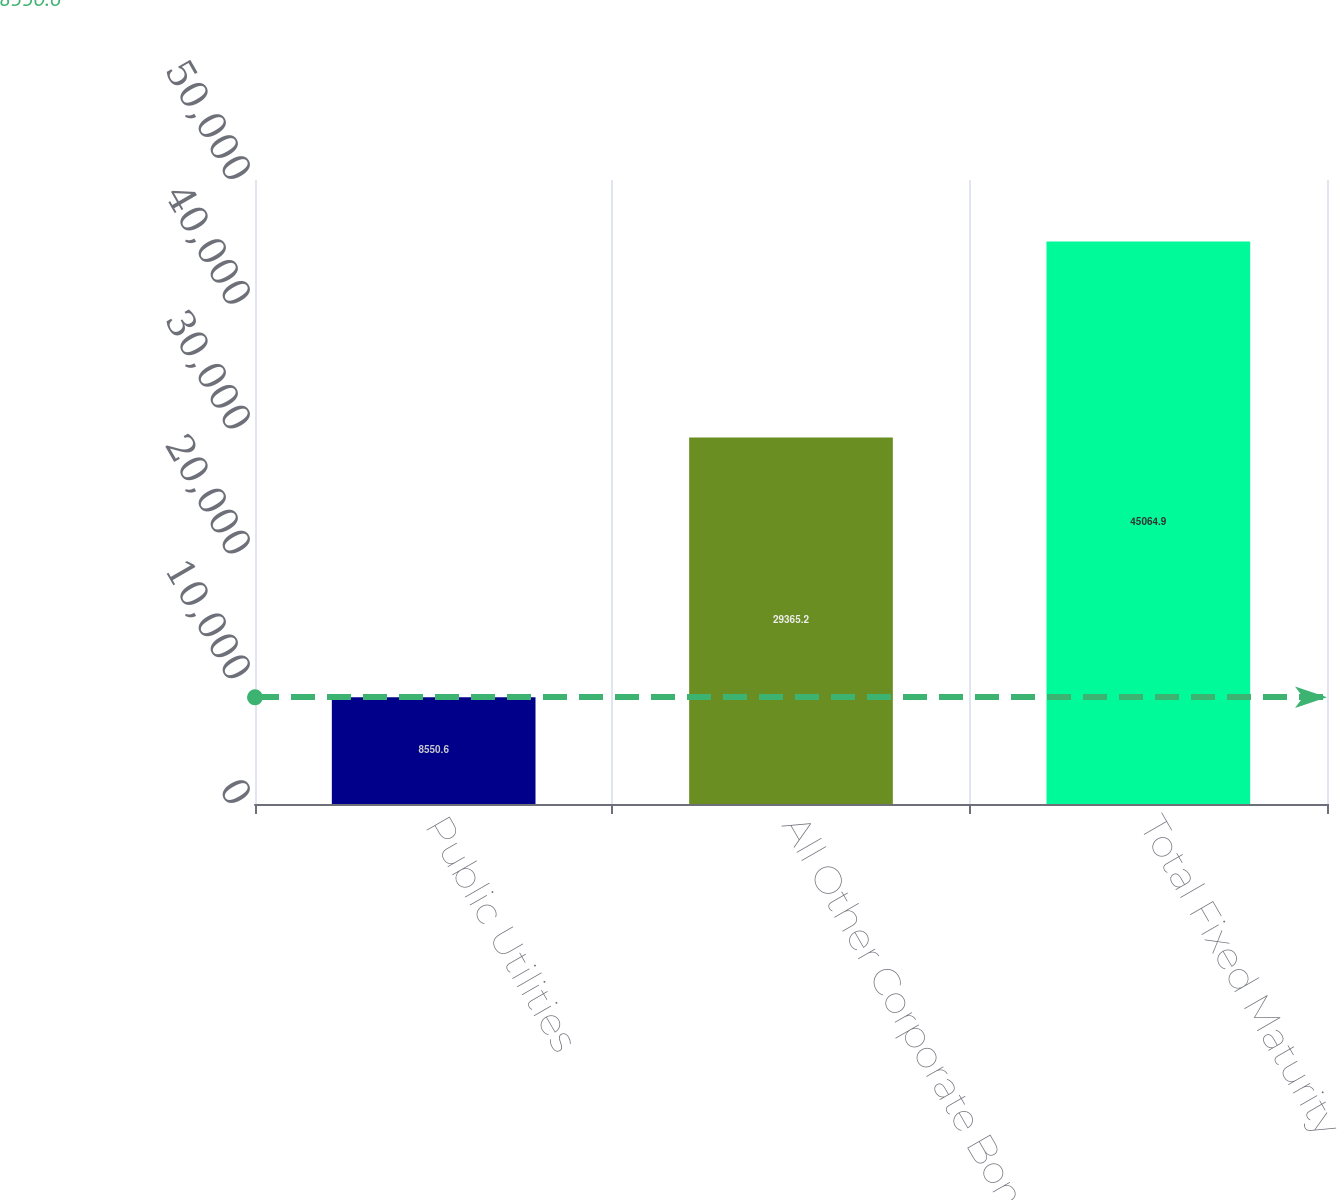<chart> <loc_0><loc_0><loc_500><loc_500><bar_chart><fcel>Public Utilities<fcel>All Other Corporate Bonds<fcel>Total Fixed Maturity<nl><fcel>8550.6<fcel>29365.2<fcel>45064.9<nl></chart> 